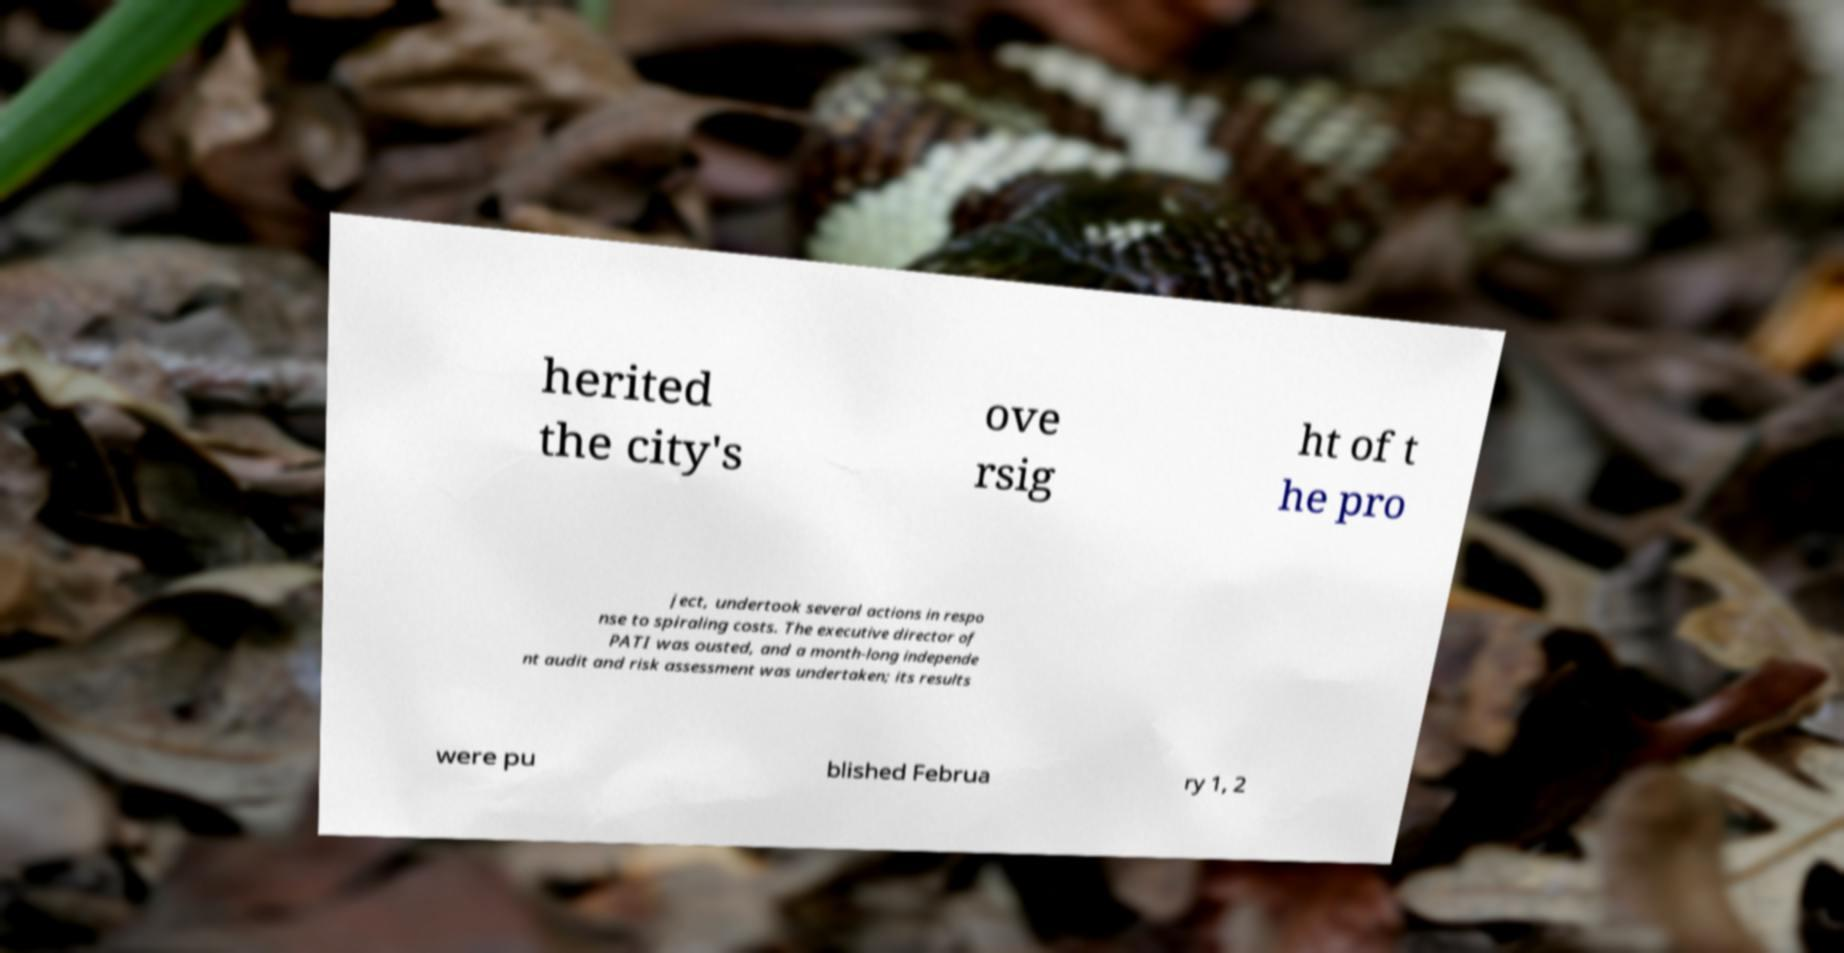What messages or text are displayed in this image? I need them in a readable, typed format. herited the city's ove rsig ht of t he pro ject, undertook several actions in respo nse to spiraling costs. The executive director of PATI was ousted, and a month-long independe nt audit and risk assessment was undertaken; its results were pu blished Februa ry 1, 2 